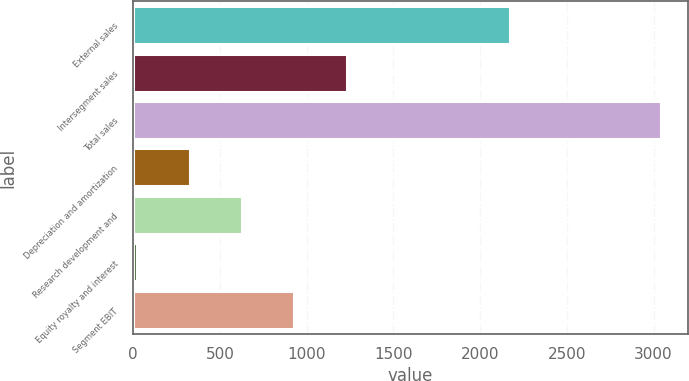<chart> <loc_0><loc_0><loc_500><loc_500><bar_chart><fcel>External sales<fcel>Intersegment sales<fcel>Total sales<fcel>Depreciation and amortization<fcel>Research development and<fcel>Equity royalty and interest<fcel>Segment EBIT<nl><fcel>2171<fcel>1232.2<fcel>3046<fcel>325.3<fcel>627.6<fcel>23<fcel>929.9<nl></chart> 